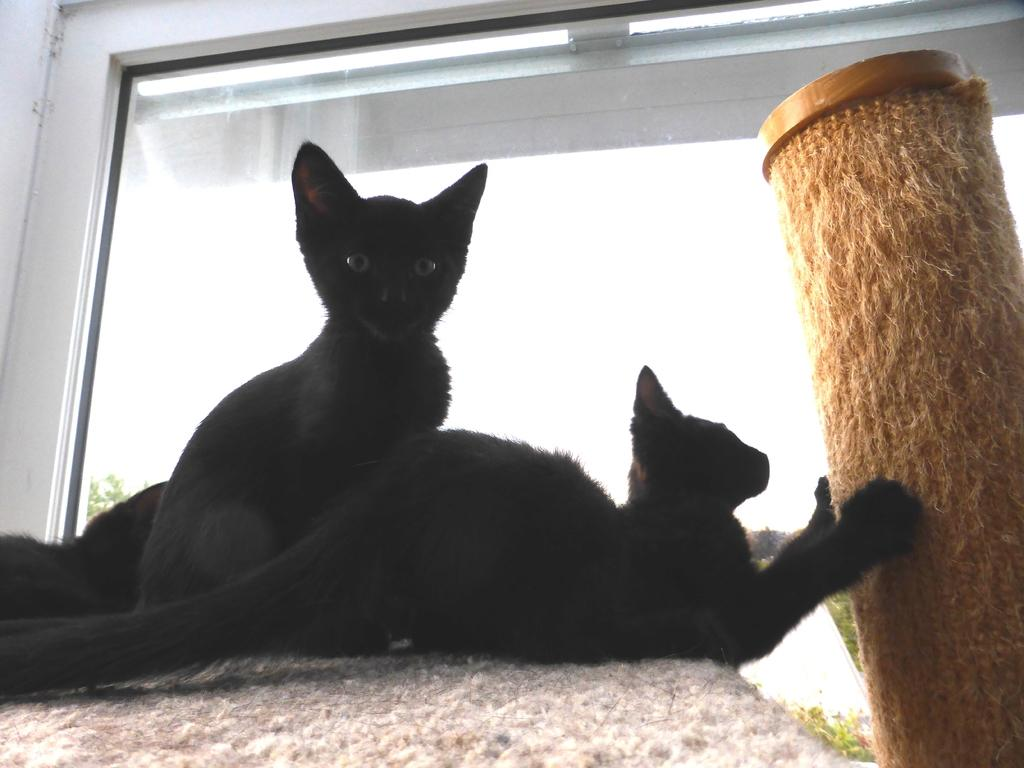How many kittens are in the image? There are two black color kittens in the image. What are the kittens doing in the image? The kittens are sitting on a table. What object is beside the kittens? There is a brown color straw roll beside the kittens. What can be seen in the background of the image? There is a glass window in the background of the image. What type of wire is being used to hold the kittens in the image? There is no wire present in the image; the kittens are sitting on a table. What kind of paste is being used to stick the kittens to the table in the image? There is no paste present in the image; the kittens are sitting on a table without any adhesive. 